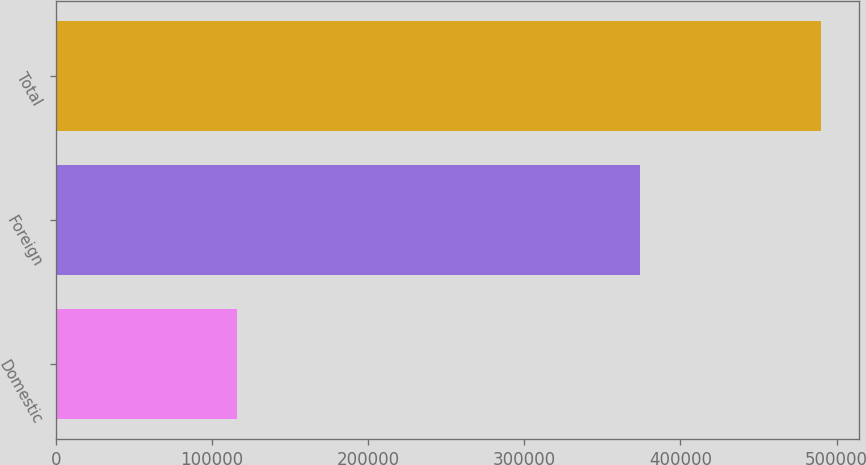Convert chart to OTSL. <chart><loc_0><loc_0><loc_500><loc_500><bar_chart><fcel>Domestic<fcel>Foreign<fcel>Total<nl><fcel>116067<fcel>374038<fcel>490105<nl></chart> 